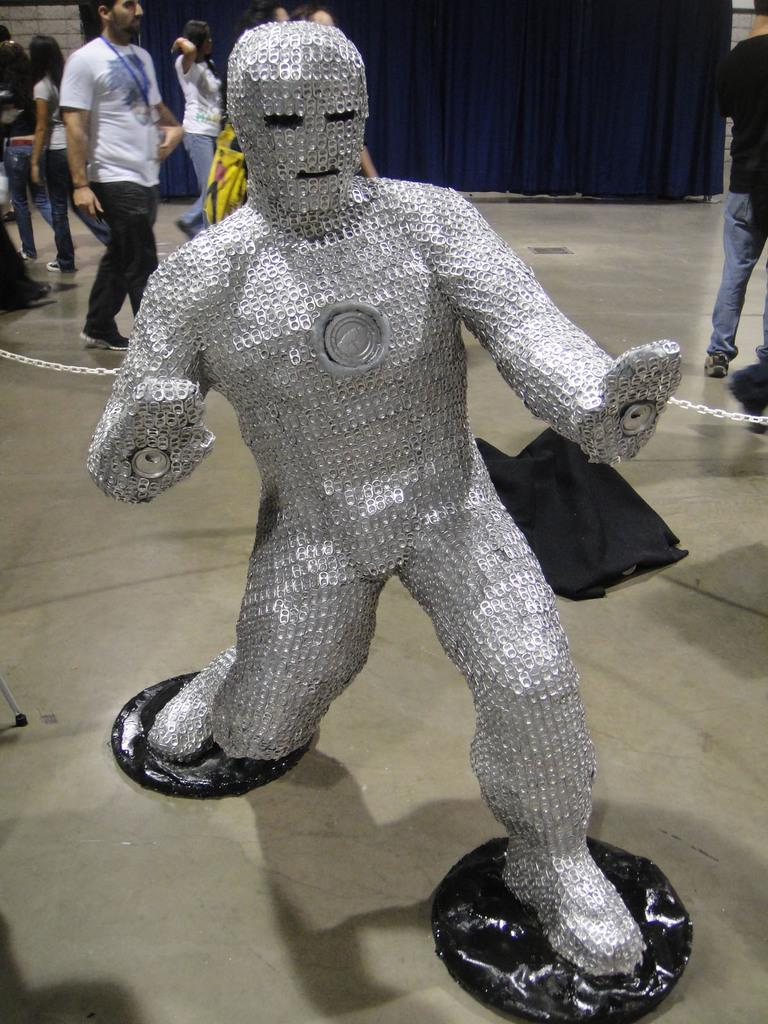What is the color of the statue in the image? The statue in the image is silver in color. What is the surface on which the statue is placed? There is a floor in the image. What are the people in the image doing? The people in the image are walking. What can be seen in the background of the image? There is a blue color curtain in the background of the image. What type of ear is visible on the statue in the image? There is no ear visible on the statue in the image, as it is a statue and does not have human features. 